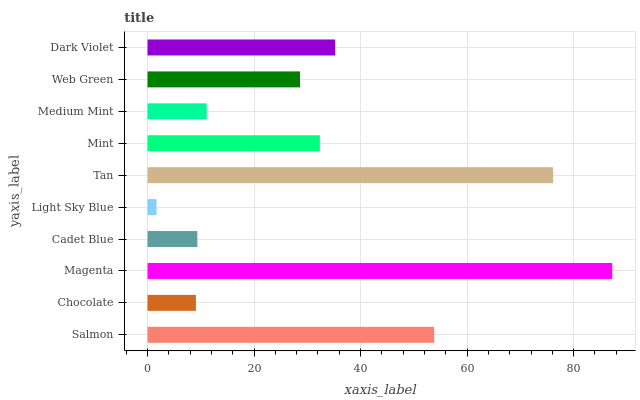Is Light Sky Blue the minimum?
Answer yes or no. Yes. Is Magenta the maximum?
Answer yes or no. Yes. Is Chocolate the minimum?
Answer yes or no. No. Is Chocolate the maximum?
Answer yes or no. No. Is Salmon greater than Chocolate?
Answer yes or no. Yes. Is Chocolate less than Salmon?
Answer yes or no. Yes. Is Chocolate greater than Salmon?
Answer yes or no. No. Is Salmon less than Chocolate?
Answer yes or no. No. Is Mint the high median?
Answer yes or no. Yes. Is Web Green the low median?
Answer yes or no. Yes. Is Salmon the high median?
Answer yes or no. No. Is Salmon the low median?
Answer yes or no. No. 